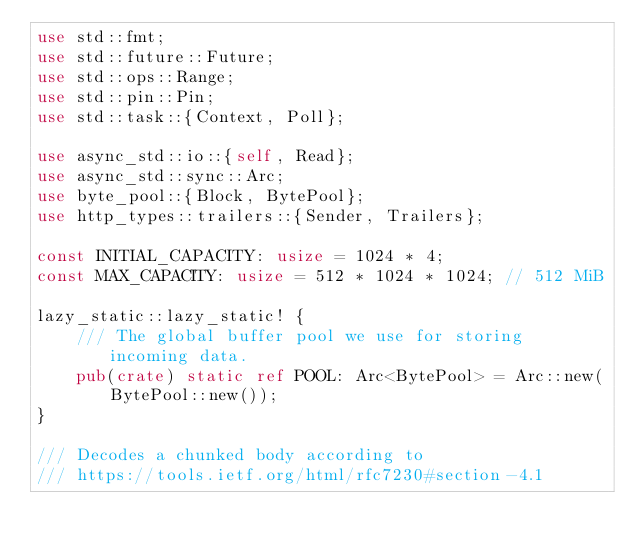<code> <loc_0><loc_0><loc_500><loc_500><_Rust_>use std::fmt;
use std::future::Future;
use std::ops::Range;
use std::pin::Pin;
use std::task::{Context, Poll};

use async_std::io::{self, Read};
use async_std::sync::Arc;
use byte_pool::{Block, BytePool};
use http_types::trailers::{Sender, Trailers};

const INITIAL_CAPACITY: usize = 1024 * 4;
const MAX_CAPACITY: usize = 512 * 1024 * 1024; // 512 MiB

lazy_static::lazy_static! {
    /// The global buffer pool we use for storing incoming data.
    pub(crate) static ref POOL: Arc<BytePool> = Arc::new(BytePool::new());
}

/// Decodes a chunked body according to
/// https://tools.ietf.org/html/rfc7230#section-4.1</code> 